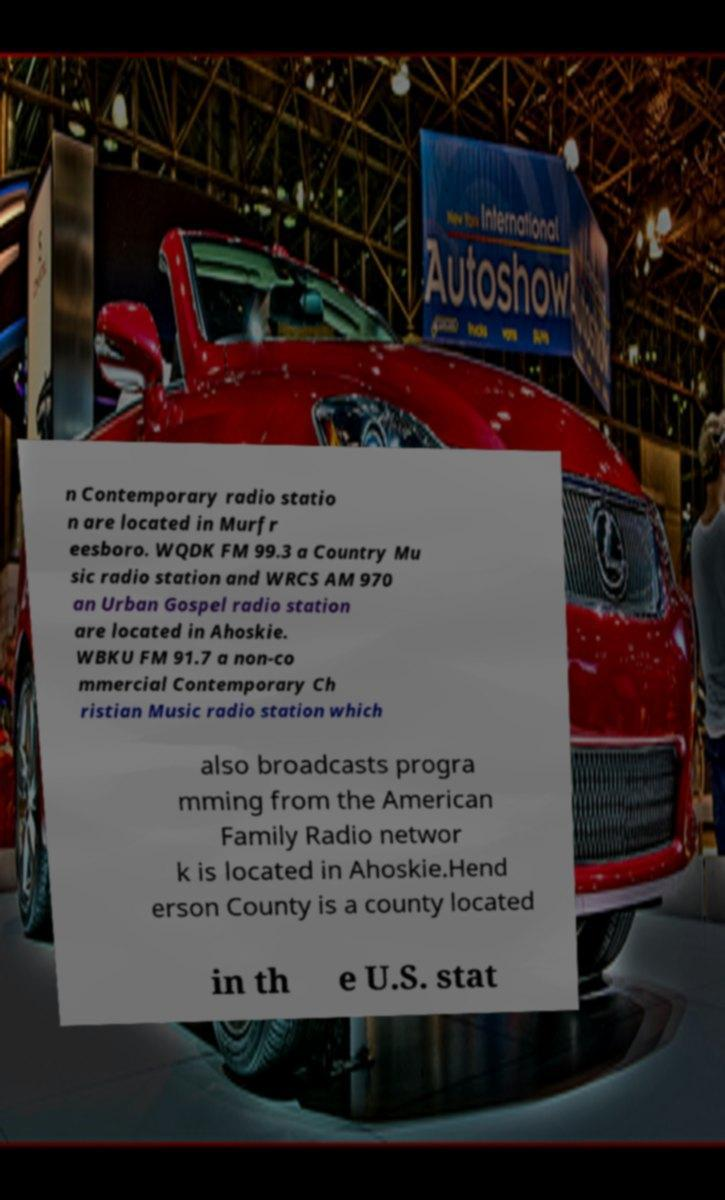There's text embedded in this image that I need extracted. Can you transcribe it verbatim? n Contemporary radio statio n are located in Murfr eesboro. WQDK FM 99.3 a Country Mu sic radio station and WRCS AM 970 an Urban Gospel radio station are located in Ahoskie. WBKU FM 91.7 a non-co mmercial Contemporary Ch ristian Music radio station which also broadcasts progra mming from the American Family Radio networ k is located in Ahoskie.Hend erson County is a county located in th e U.S. stat 